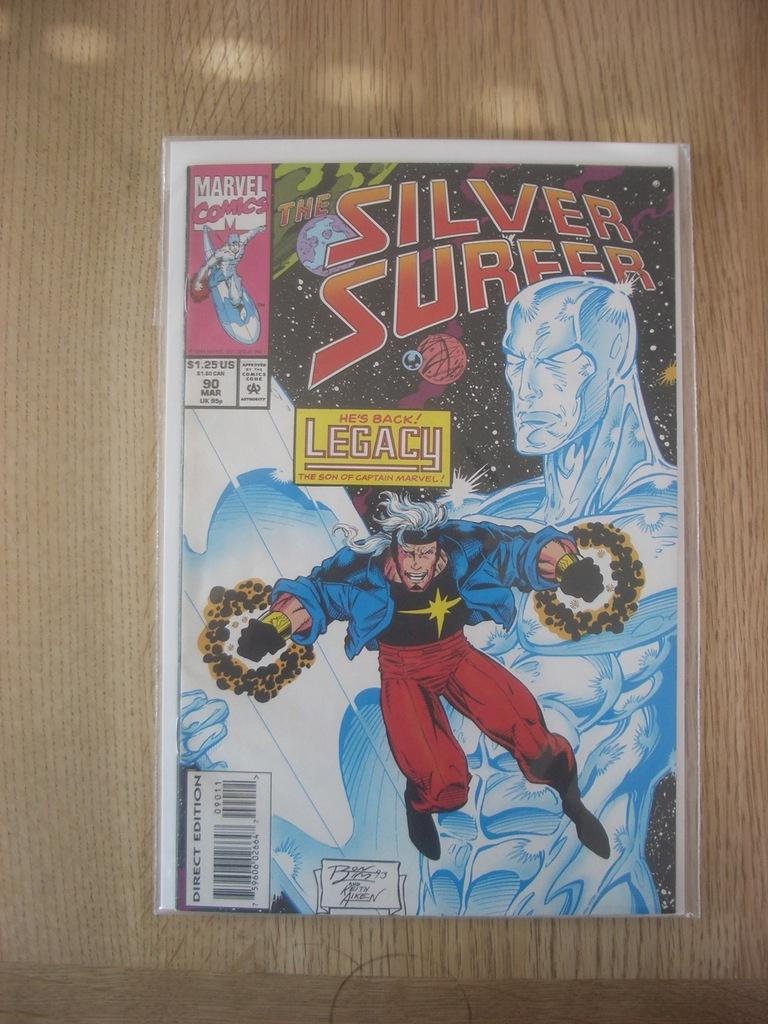<image>
Give a short and clear explanation of the subsequent image. The cover of a Marvel Comic, The Silver Surfer, is shown. 